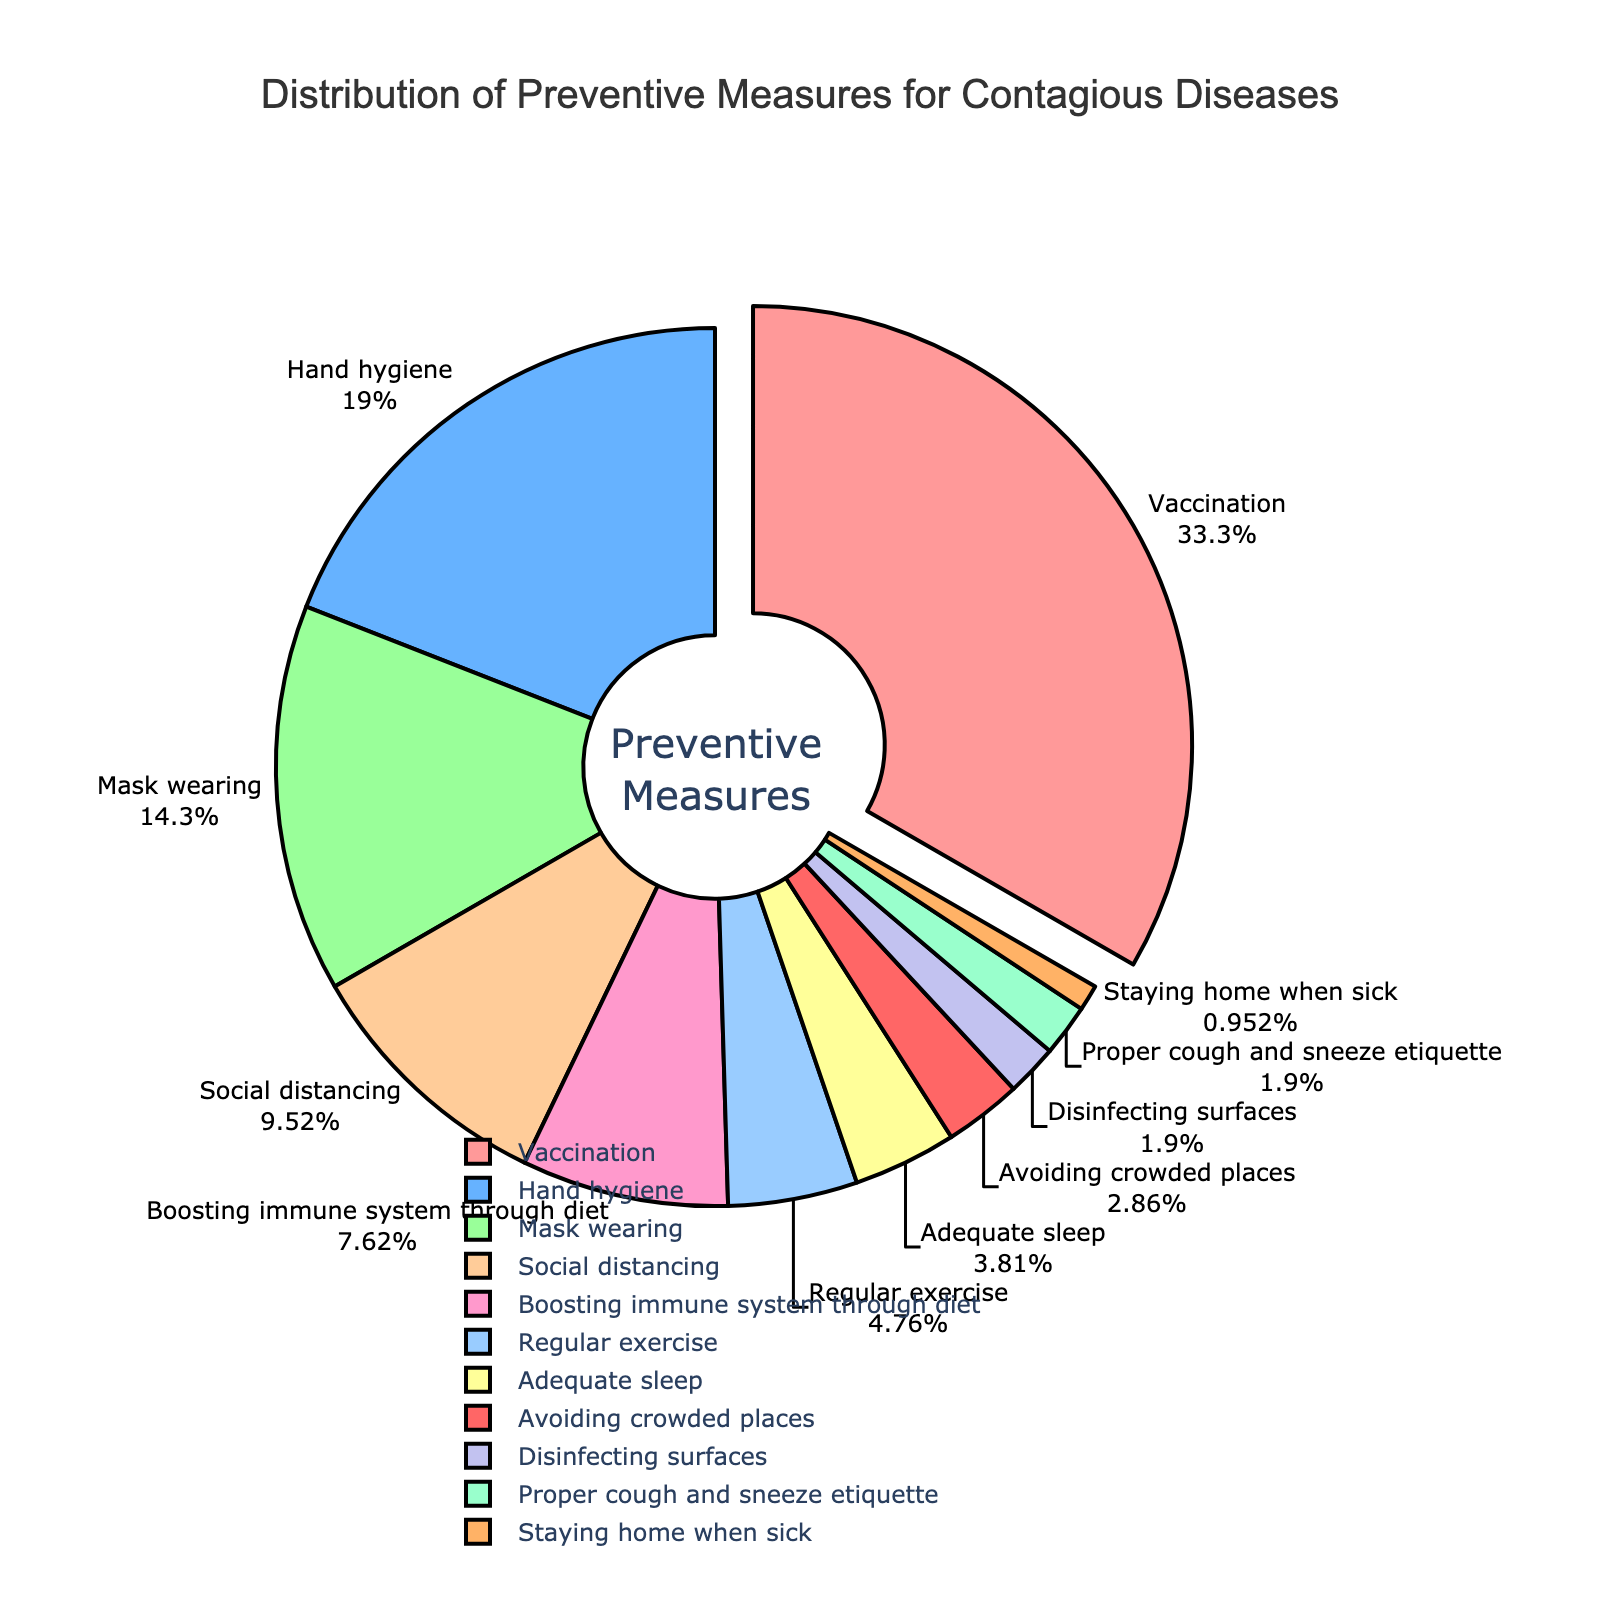What's the largest percentage represented in the chart? The segment "Vaccination" occupies the largest area in the pie chart.
Answer: Vaccination (35%) Which preventive measure has a percentage half that of "Hand hygiene"? "Hand hygiene" has 20%. Half of this is 10%, which corresponds to "Social distancing".
Answer: Social distancing (10%) How much greater is the percentage for "Vaccination" compared to "Mask wearing"? The percentage for "Vaccination" is 35%, while "Mask wearing" is 15%. The difference is 35% - 15% = 20%.
Answer: 20% Which two preventive measures have the smallest and second smallest percentages, respectively? The smallest percentage is "Staying home when sick" (1%), followed by "Proper cough and sneeze etiquette" (2%).
Answer: Staying home when sick (1%) and Proper cough and sneeze etiquette (2%) If you sum the percentages of "Regular exercise", "Adequate sleep", and "Avoiding crowded places", what is the total? Regular exercise is 5%, Adequate sleep is 4%, and Avoiding crowded places is 3%. Summing these gives 5% + 4% + 3% = 12%.
Answer: 12% Which preventive measure is represented by the green segment in the pie chart? The green segment corresponds to "Hand hygiene".
Answer: Hand hygiene How many preventive measures have a percentage greater than or equal to 10%? "Vaccination" (35%), "Hand hygiene" (20%), "Mask wearing" (15%), and "Social distancing" (10%) are all greater than or equal to 10%. There are 4 such measures.
Answer: 4 What is the average percentage of the three least common preventive measures? The three least common measures are "Staying home when sick" (1%), "Proper cough and sneeze etiquette" (2%), and "Disinfecting surfaces" (2%). The average is (1% + 2% + 2%) / 3 = 1.67%.
Answer: 1.67% 